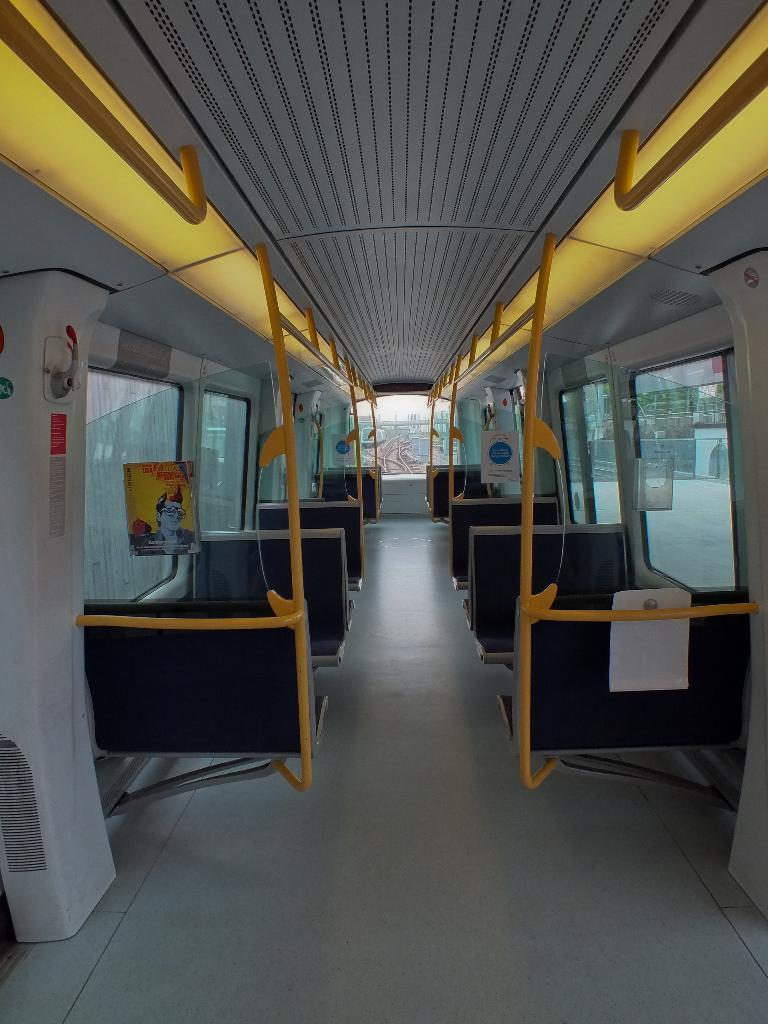What type of furniture is present in the image? There are seats in the image. What is the color of the pole in the image? The pole in the image is yellow. What type of material is used for the windows in the image? The windows in the image are made of glass. What is the color of the floor in the image? The floor in the image is white. What is attached to the glass windows in the image? A poster is attached to the glass windows. How many songs can be heard coming from the slave in the image? There is no slave or singing in the image; it features seats, a yellow pole, glass windows, a white floor, and a poster. What type of duck is visible in the image? There are no ducks present in the image. 